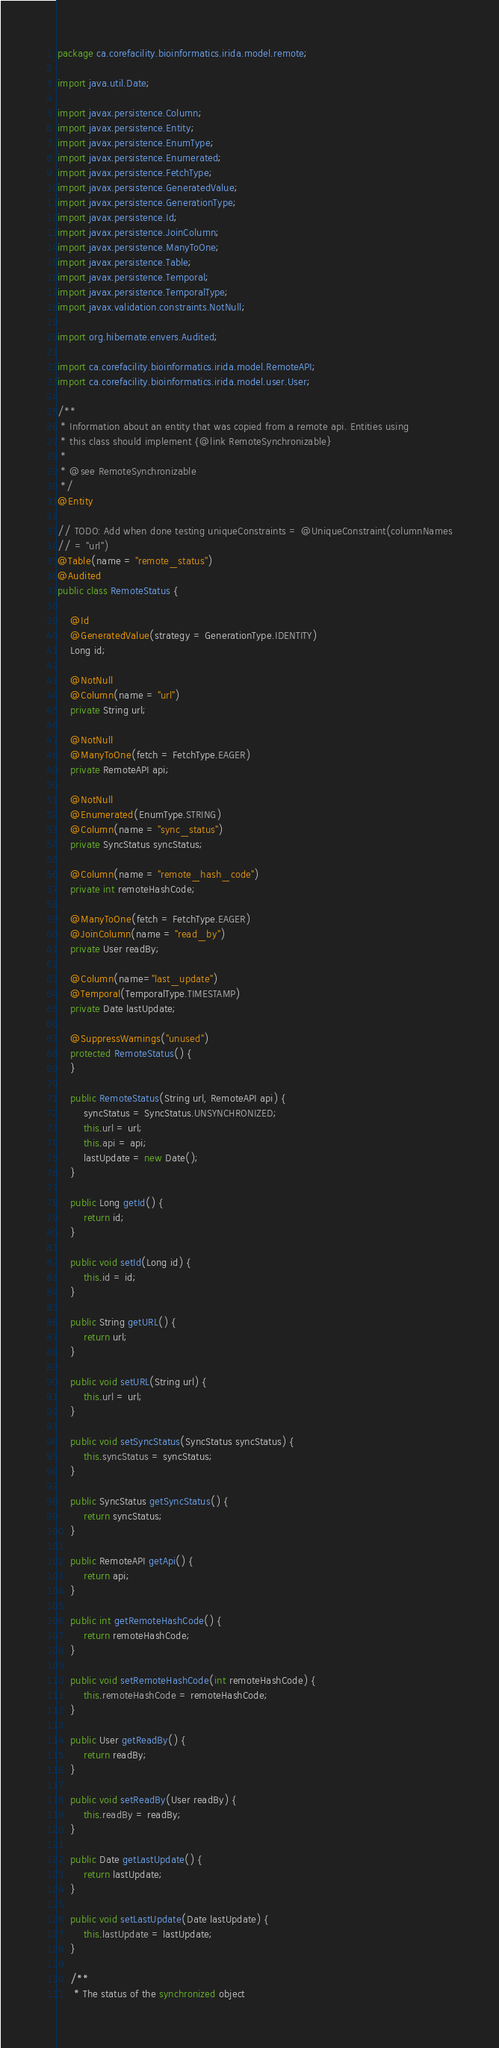<code> <loc_0><loc_0><loc_500><loc_500><_Java_>package ca.corefacility.bioinformatics.irida.model.remote;

import java.util.Date;

import javax.persistence.Column;
import javax.persistence.Entity;
import javax.persistence.EnumType;
import javax.persistence.Enumerated;
import javax.persistence.FetchType;
import javax.persistence.GeneratedValue;
import javax.persistence.GenerationType;
import javax.persistence.Id;
import javax.persistence.JoinColumn;
import javax.persistence.ManyToOne;
import javax.persistence.Table;
import javax.persistence.Temporal;
import javax.persistence.TemporalType;
import javax.validation.constraints.NotNull;

import org.hibernate.envers.Audited;

import ca.corefacility.bioinformatics.irida.model.RemoteAPI;
import ca.corefacility.bioinformatics.irida.model.user.User;

/**
 * Information about an entity that was copied from a remote api. Entities using
 * this class should implement {@link RemoteSynchronizable}
 * 
 * @see RemoteSynchronizable
 */
@Entity

// TODO: Add when done testing uniqueConstraints = @UniqueConstraint(columnNames
// = "url")
@Table(name = "remote_status")
@Audited
public class RemoteStatus {

	@Id
	@GeneratedValue(strategy = GenerationType.IDENTITY)
	Long id;

	@NotNull
	@Column(name = "url")
	private String url;

	@NotNull
	@ManyToOne(fetch = FetchType.EAGER)
	private RemoteAPI api;

	@NotNull
	@Enumerated(EnumType.STRING)
	@Column(name = "sync_status")
	private SyncStatus syncStatus;

	@Column(name = "remote_hash_code")
	private int remoteHashCode;

	@ManyToOne(fetch = FetchType.EAGER)
	@JoinColumn(name = "read_by")
	private User readBy;

	@Column(name="last_update")
	@Temporal(TemporalType.TIMESTAMP)
	private Date lastUpdate;

	@SuppressWarnings("unused")
	protected RemoteStatus() {
	}

	public RemoteStatus(String url, RemoteAPI api) {
		syncStatus = SyncStatus.UNSYNCHRONIZED;
		this.url = url;
		this.api = api;
		lastUpdate = new Date();
	}

	public Long getId() {
		return id;
	}

	public void setId(Long id) {
		this.id = id;
	}

	public String getURL() {
		return url;
	}

	public void setURL(String url) {
		this.url = url;
	}

	public void setSyncStatus(SyncStatus syncStatus) {
		this.syncStatus = syncStatus;
	}

	public SyncStatus getSyncStatus() {
		return syncStatus;
	}

	public RemoteAPI getApi() {
		return api;
	}

	public int getRemoteHashCode() {
		return remoteHashCode;
	}

	public void setRemoteHashCode(int remoteHashCode) {
		this.remoteHashCode = remoteHashCode;
	}

	public User getReadBy() {
		return readBy;
	}

	public void setReadBy(User readBy) {
		this.readBy = readBy;
	}

	public Date getLastUpdate() {
		return lastUpdate;
	}

	public void setLastUpdate(Date lastUpdate) {
		this.lastUpdate = lastUpdate;
	}

	/**
	 * The status of the synchronized object</code> 